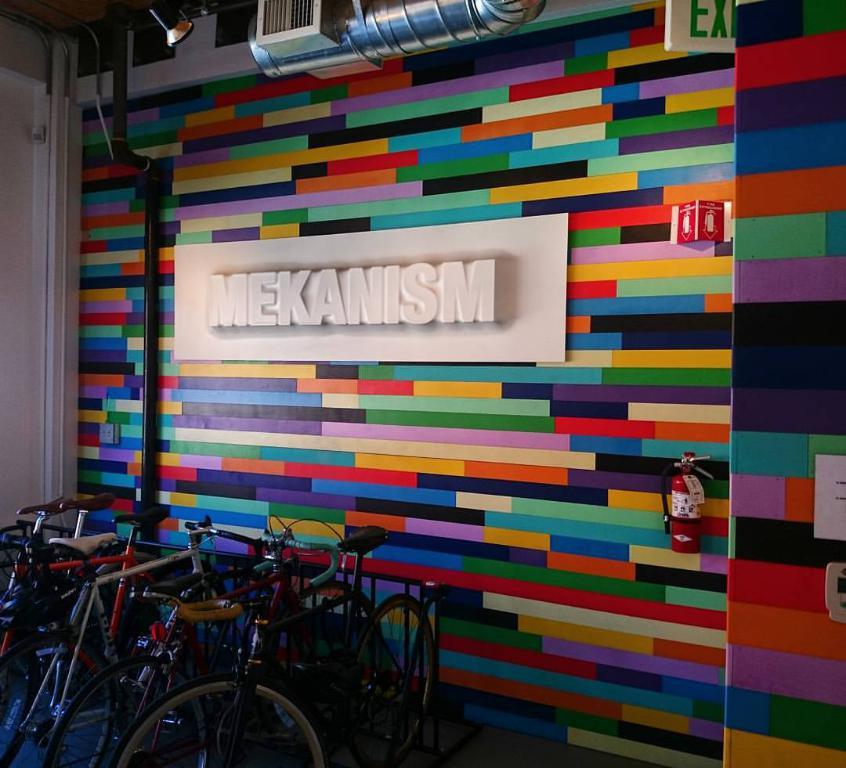<image>
Describe the image concisely. Bikes on the stand with a background of advertisement for brand " Mekanism". 